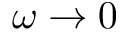Convert formula to latex. <formula><loc_0><loc_0><loc_500><loc_500>\omega \rightarrow 0</formula> 